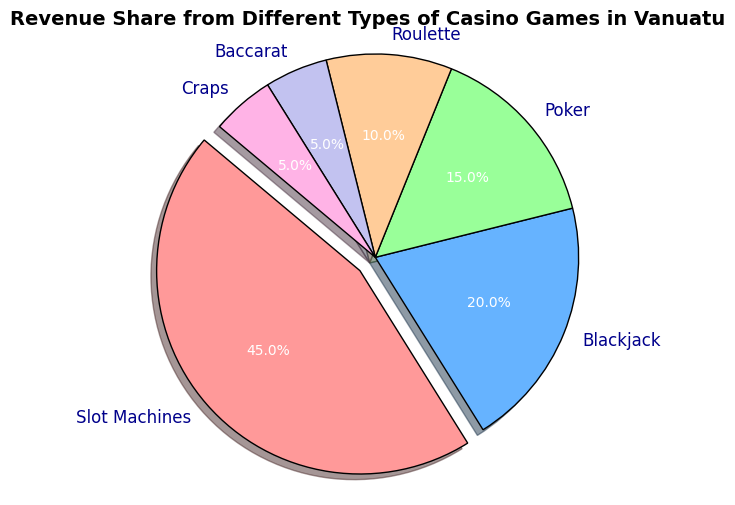What percentage of the total revenue comes from Poker and Roulette combined? To calculate this, add the revenue share percentages of Poker and Roulette. According to the pie chart, Poker contributes 15% and Roulette contributes 10%. Therefore, the combined revenue share is 15% + 10% = 25%.
Answer: 25% Which game type has the highest revenue share, and what is its percentage? By looking at the pie chart, the largest slice is highlighted by being slightly detached from the rest of the chart. This slice represents Slot Machines. Therefore, the game type with the highest revenue share is Slot Machines, which has a revenue share of 45%.
Answer: Slot Machines, 45% Is the revenue share of Blackjack greater than the combined revenue share of Baccarat and Craps? According to the pie chart, the revenue share for Blackjack is 20%. The combined revenue share of Baccarat and Craps is 5% + 5% = 10%. Since 20% is greater than 10%, the revenue share of Blackjack is indeed greater.
Answer: Yes Which game types have an equal revenue share, and what is their value? Observing the pie chart, both Baccarat and Craps have equal slices. Each of these game types has a revenue share of 5%.
Answer: Baccarat and Craps, 5% What is the difference in revenue share between Slot Machines and Poker? The revenue share for Slot Machines is 45%, and for Poker, it is 15%. The difference is obtained by subtracting 15% from 45%, which is 45% - 15% = 30%.
Answer: 30% What color is used to represent Roulette on the chart? Roulette is represented by the fourth slice when counting clockwise from the top. The color used for this slice is a light orange shade.
Answer: Light Orange 